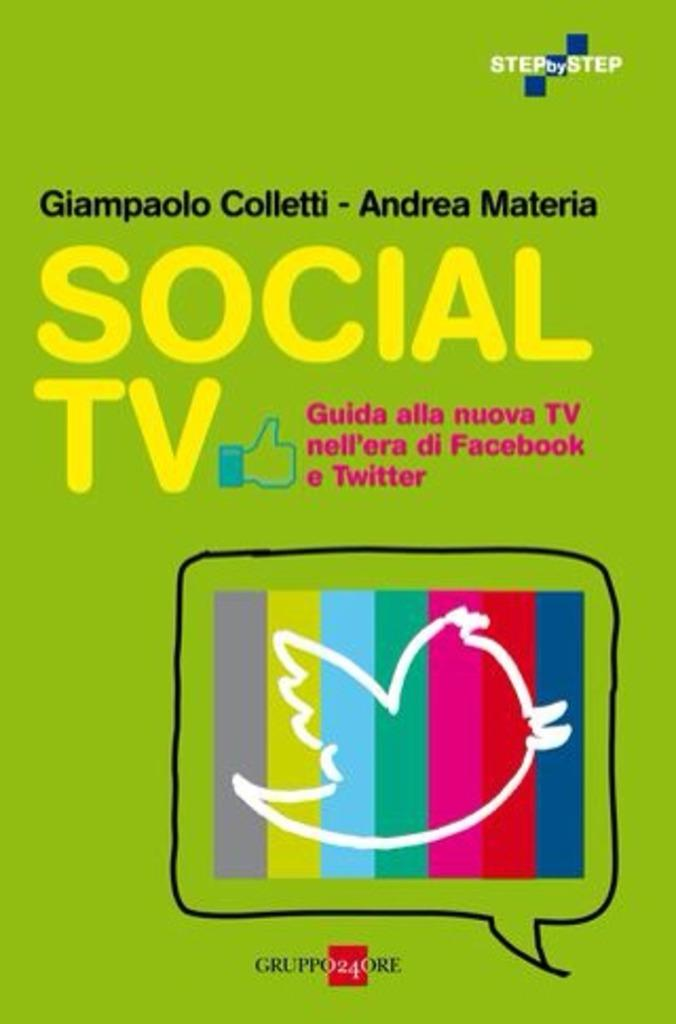<image>
Give a short and clear explanation of the subsequent image. Poster for Social TV with a thumbs up sign next to it. 